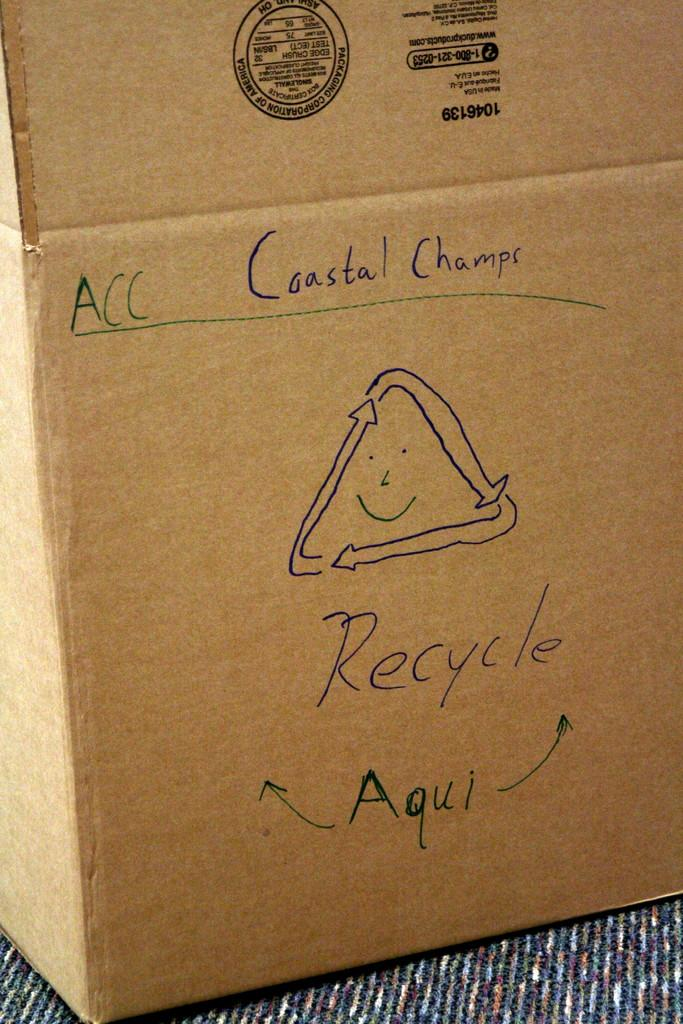What object is present on a platform in the image? There is a carton box on a platform in the image. What is written on the carton box? There is text written on the carton box. What type of symbol is present on the carton box? There is a logo on the carton box. Can you see a monkey holding a letter near the stream in the image? There is no monkey, letter, or stream present in the image. 